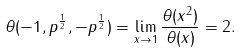<formula> <loc_0><loc_0><loc_500><loc_500>\theta ( - 1 , p ^ { \frac { 1 } { 2 } } , - p ^ { \frac { 1 } { 2 } } ) = \lim _ { x \rightarrow 1 } \frac { \theta ( x ^ { 2 } ) } { \theta ( x ) } = 2 .</formula> 